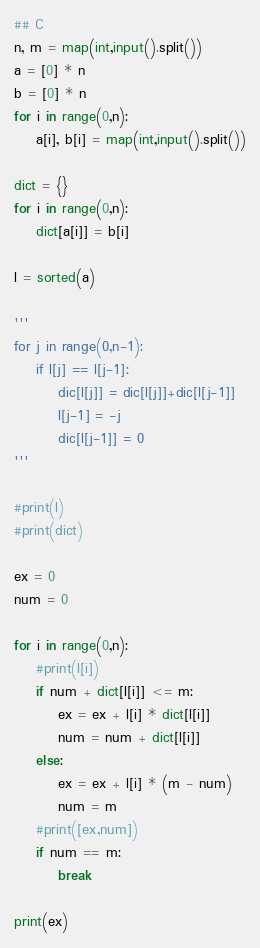<code> <loc_0><loc_0><loc_500><loc_500><_Python_>## C
n, m = map(int,input().split())
a = [0] * n
b = [0] * n
for i in range(0,n):
    a[i], b[i] = map(int,input().split())

dict = {}
for i in range(0,n):
    dict[a[i]] = b[i]

l = sorted(a)

'''
for j in range(0,n-1):
    if l[j] == l[j-1]:
        dic[l[j]] = dic[l[j]]+dic[l[j-1]]
        l[j-1] = -j
        dic[l[j-1]] = 0
'''

#print(l)
#print(dict)

ex = 0
num = 0

for i in range(0,n):
    #print(l[i])
    if num + dict[l[i]] <= m:
        ex = ex + l[i] * dict[l[i]]
        num = num + dict[l[i]]
    else:
        ex = ex + l[i] * (m - num)
        num = m
    #print([ex,num])
    if num == m:
        break

print(ex)




</code> 